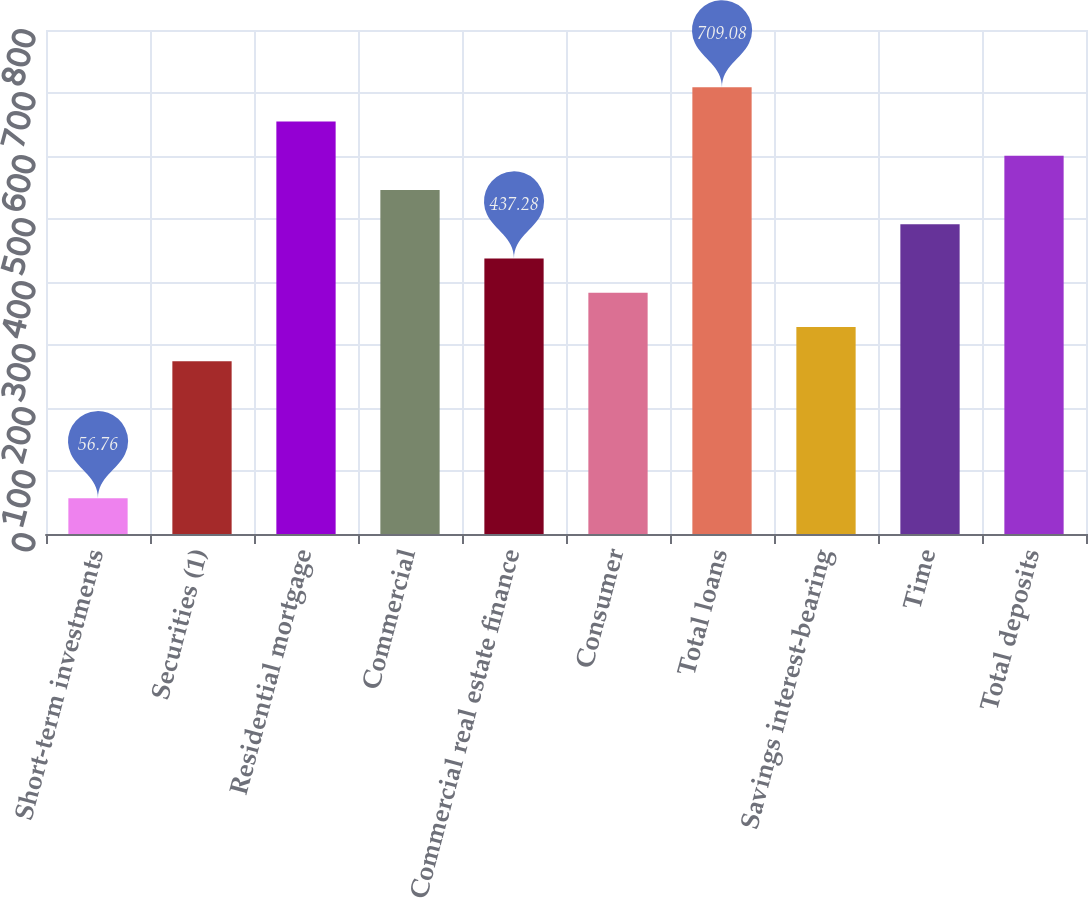Convert chart to OTSL. <chart><loc_0><loc_0><loc_500><loc_500><bar_chart><fcel>Short-term investments<fcel>Securities (1)<fcel>Residential mortgage<fcel>Commercial<fcel>Commercial real estate finance<fcel>Consumer<fcel>Total loans<fcel>Savings interest-bearing<fcel>Time<fcel>Total deposits<nl><fcel>56.76<fcel>274.2<fcel>654.72<fcel>546<fcel>437.28<fcel>382.92<fcel>709.08<fcel>328.56<fcel>491.64<fcel>600.36<nl></chart> 